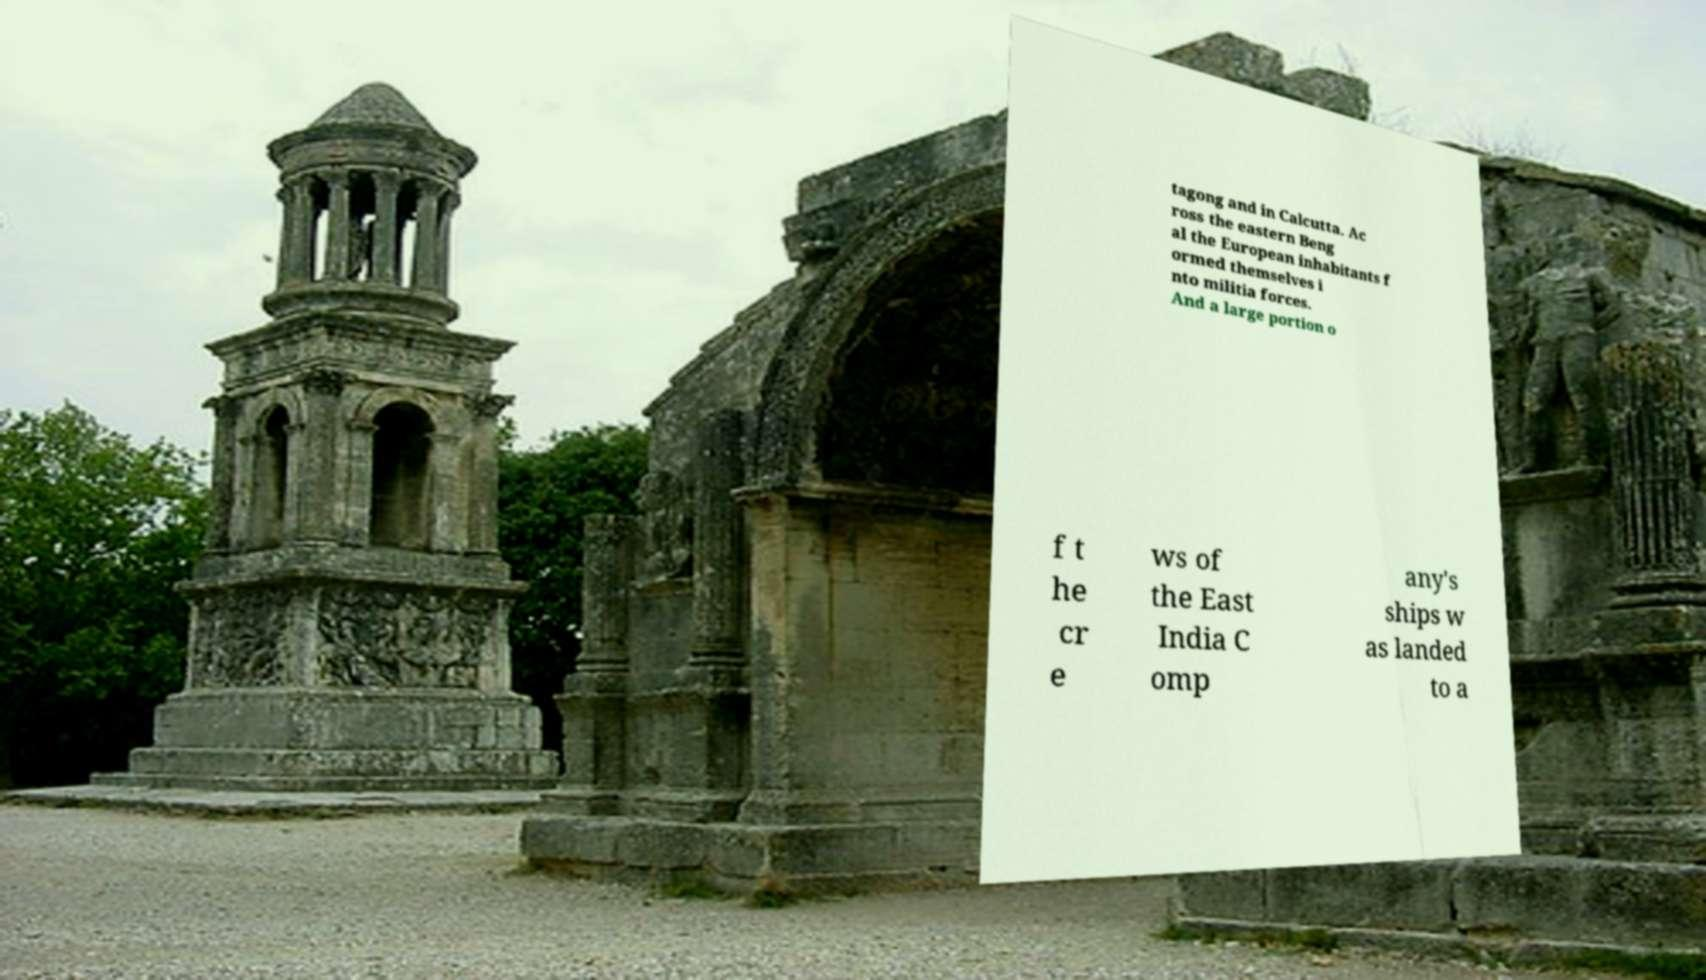What messages or text are displayed in this image? I need them in a readable, typed format. tagong and in Calcutta. Ac ross the eastern Beng al the European inhabitants f ormed themselves i nto militia forces. And a large portion o f t he cr e ws of the East India C omp any's ships w as landed to a 